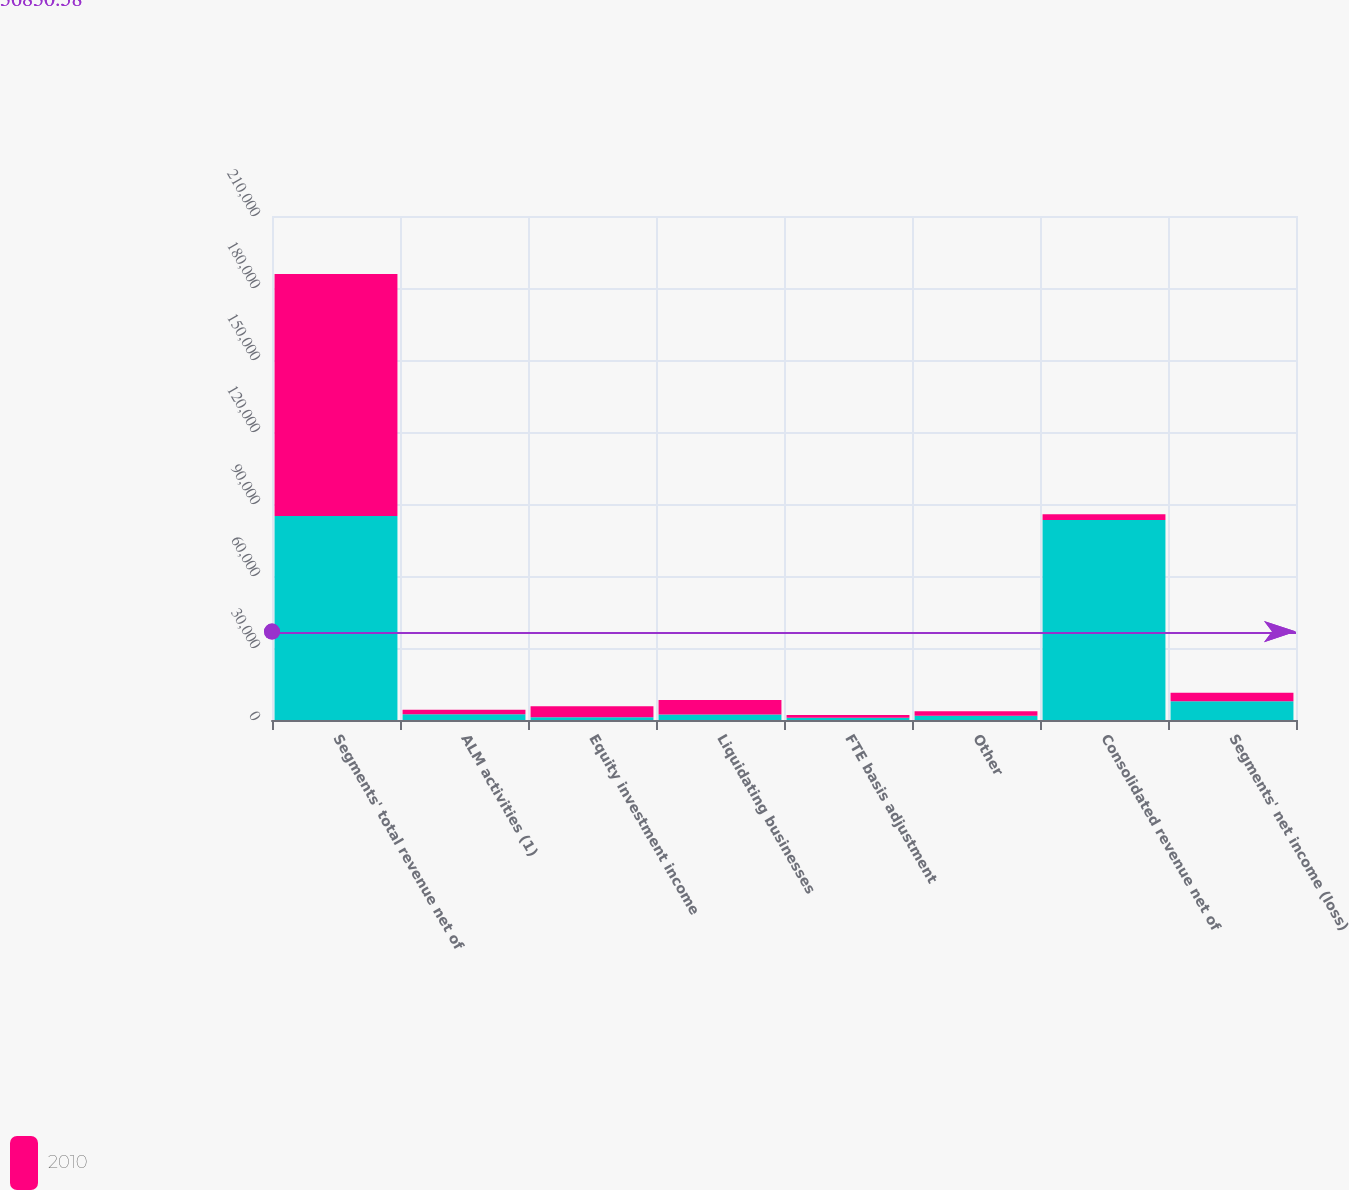Convert chart to OTSL. <chart><loc_0><loc_0><loc_500><loc_500><stacked_bar_chart><ecel><fcel>Segments' total revenue net of<fcel>ALM activities (1)<fcel>Equity investment income<fcel>Liquidating businesses<fcel>FTE basis adjustment<fcel>Other<fcel>Consolidated revenue net of<fcel>Segments' net income (loss)<nl><fcel>nan<fcel>85025<fcel>2412<fcel>1135<fcel>2279<fcel>901<fcel>1792<fcel>83334<fcel>7816<nl><fcel>2010<fcel>100774<fcel>1872<fcel>4629<fcel>6005<fcel>1170<fcel>1890<fcel>2412<fcel>3545<nl></chart> 